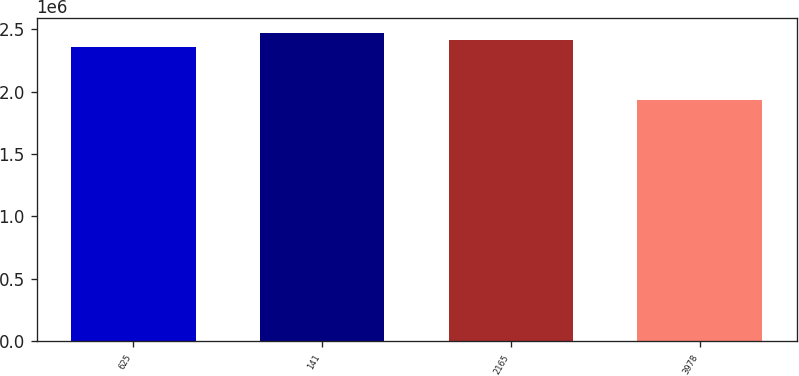Convert chart to OTSL. <chart><loc_0><loc_0><loc_500><loc_500><bar_chart><fcel>625<fcel>141<fcel>2165<fcel>3978<nl><fcel>2.36113e+06<fcel>2.46702e+06<fcel>2.41407e+06<fcel>1.93592e+06<nl></chart> 